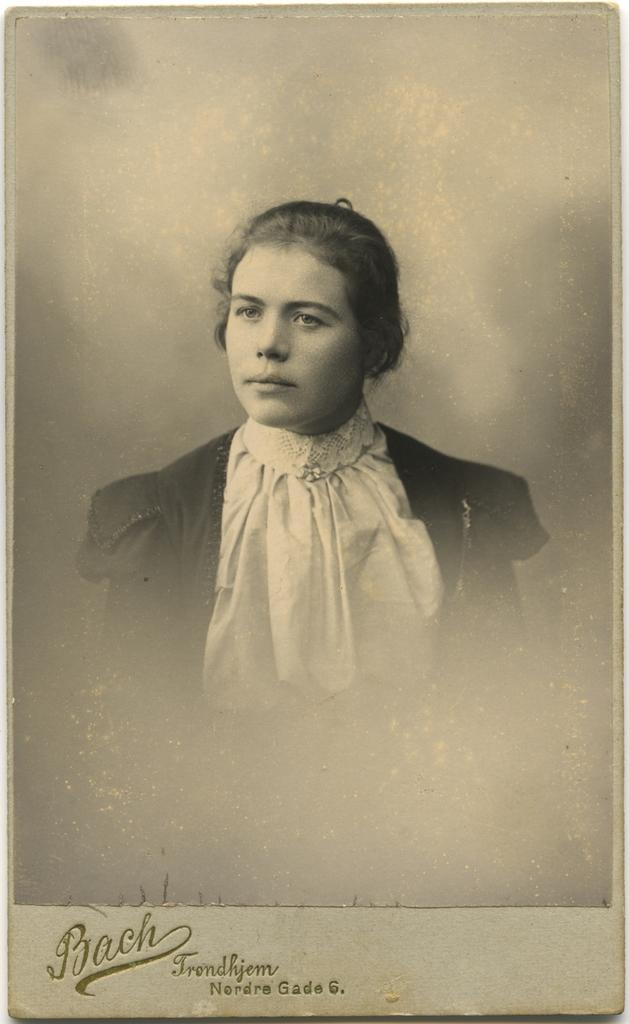What is the main object in the image? There is a poster in the image. What is depicted on the poster? The poster contains a picture of a woman. Is there any text on the poster? Yes, there is text written on the poster. Is the woman driving a car in the image? There is no car or driving depicted in the image; it only features a poster with a picture of a woman. What type of amusement can be seen on the woman's face in the image? There is no face present in the image, as it only features a poster with a picture of a woman. 